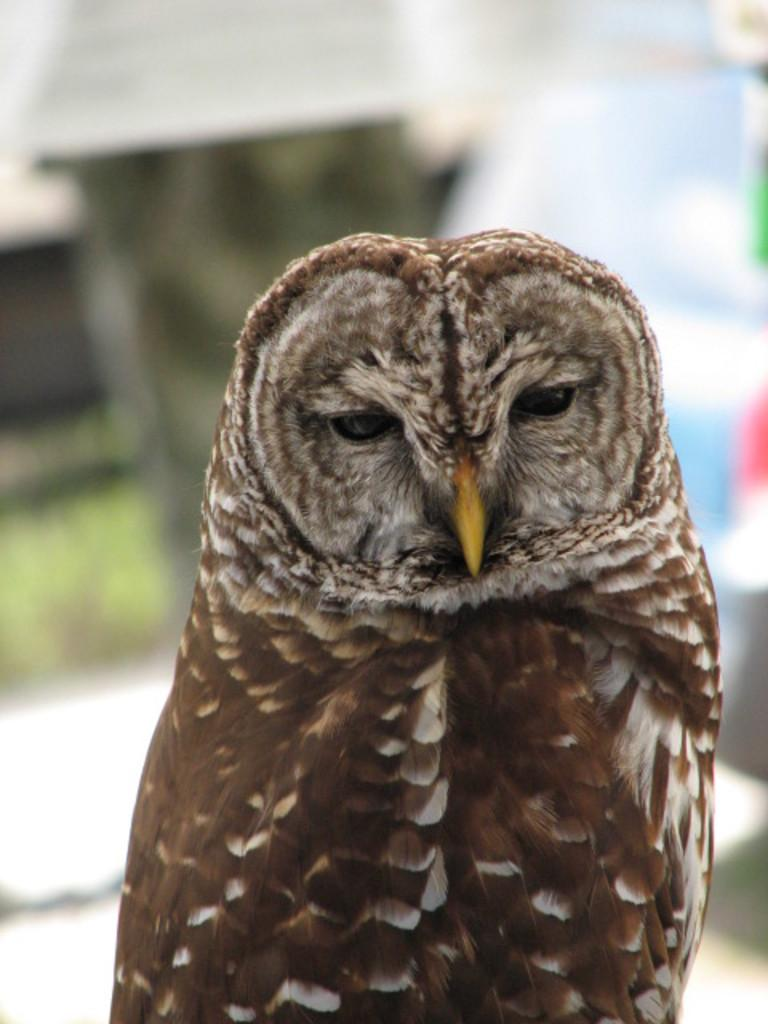What type of animal is the main subject in the image? There is an owl in the image. Can you describe the position of the owl in the image? The owl is standing in the front of the image. How would you describe the background of the image? The background of the image is blurry. What is the weight of the dog in the image? There is no dog present in the image; it features an owl. What color is the tongue of the owl in the image? Owls do not have tongues like mammals, so there is no tongue to describe in the image. 